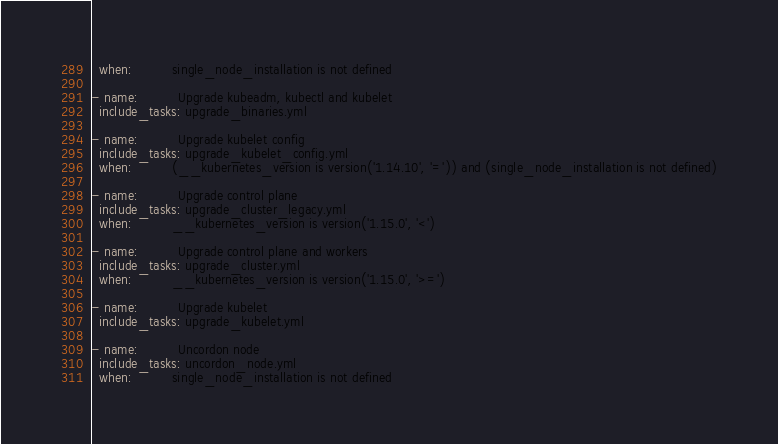<code> <loc_0><loc_0><loc_500><loc_500><_YAML_>  when:          single_node_installation is not defined

- name:          Upgrade kubeadm, kubectl and kubelet
  include_tasks: upgrade_binaries.yml

- name:          Upgrade kubelet config
  include_tasks: upgrade_kubelet_config.yml
  when:          (__kubernetes_version is version('1.14.10', '=')) and (single_node_installation is not defined)

- name:          Upgrade control plane
  include_tasks: upgrade_cluster_legacy.yml
  when:          __kubernetes_version is version('1.15.0', '<')

- name:          Upgrade control plane and workers
  include_tasks: upgrade_cluster.yml
  when:          __kubernetes_version is version('1.15.0', '>=')

- name:          Upgrade kubelet
  include_tasks: upgrade_kubelet.yml

- name:          Uncordon node
  include_tasks: uncordon_node.yml 
  when:          single_node_installation is not defined
</code> 